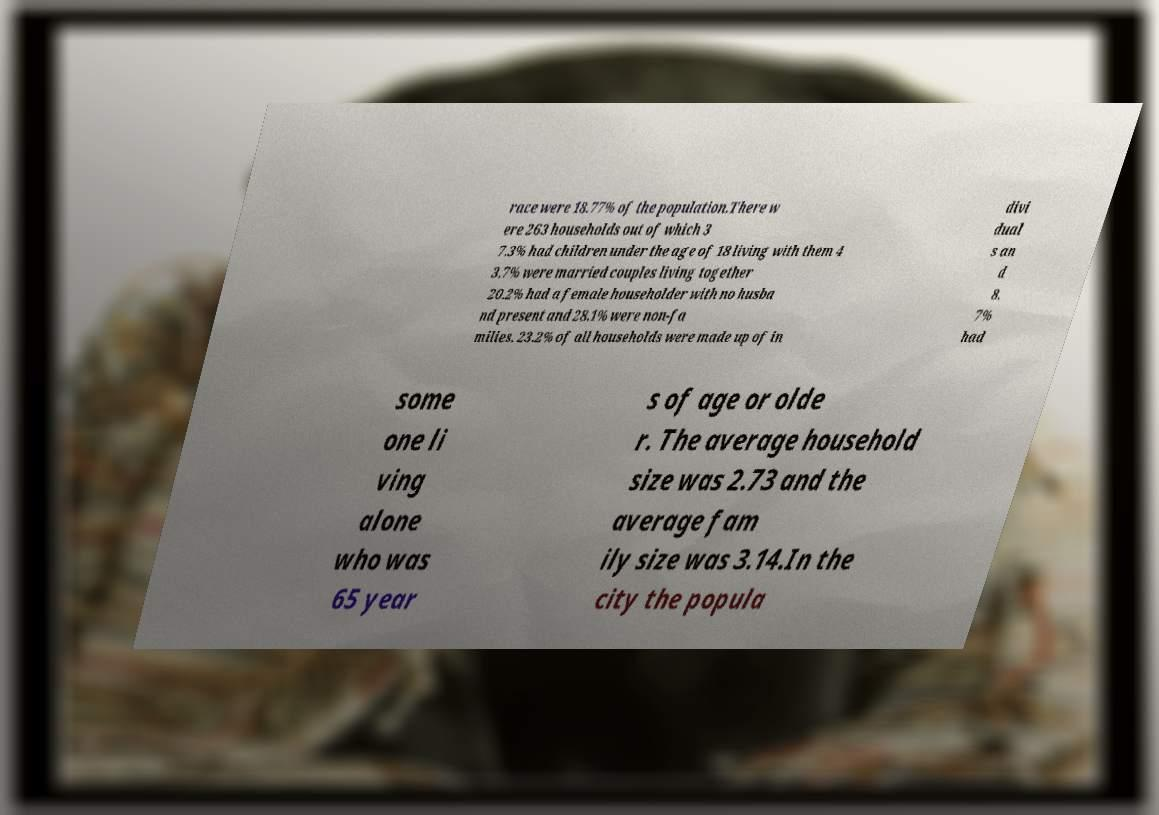Please identify and transcribe the text found in this image. race were 18.77% of the population.There w ere 263 households out of which 3 7.3% had children under the age of 18 living with them 4 3.7% were married couples living together 20.2% had a female householder with no husba nd present and 28.1% were non-fa milies. 23.2% of all households were made up of in divi dual s an d 8. 7% had some one li ving alone who was 65 year s of age or olde r. The average household size was 2.73 and the average fam ily size was 3.14.In the city the popula 